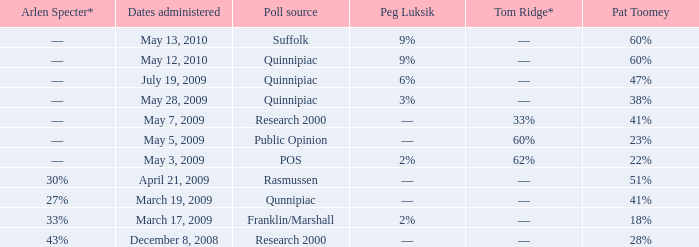Which Poll source has an Arlen Specter* of ––, and a Tom Ridge* of 60%? Public Opinion. 